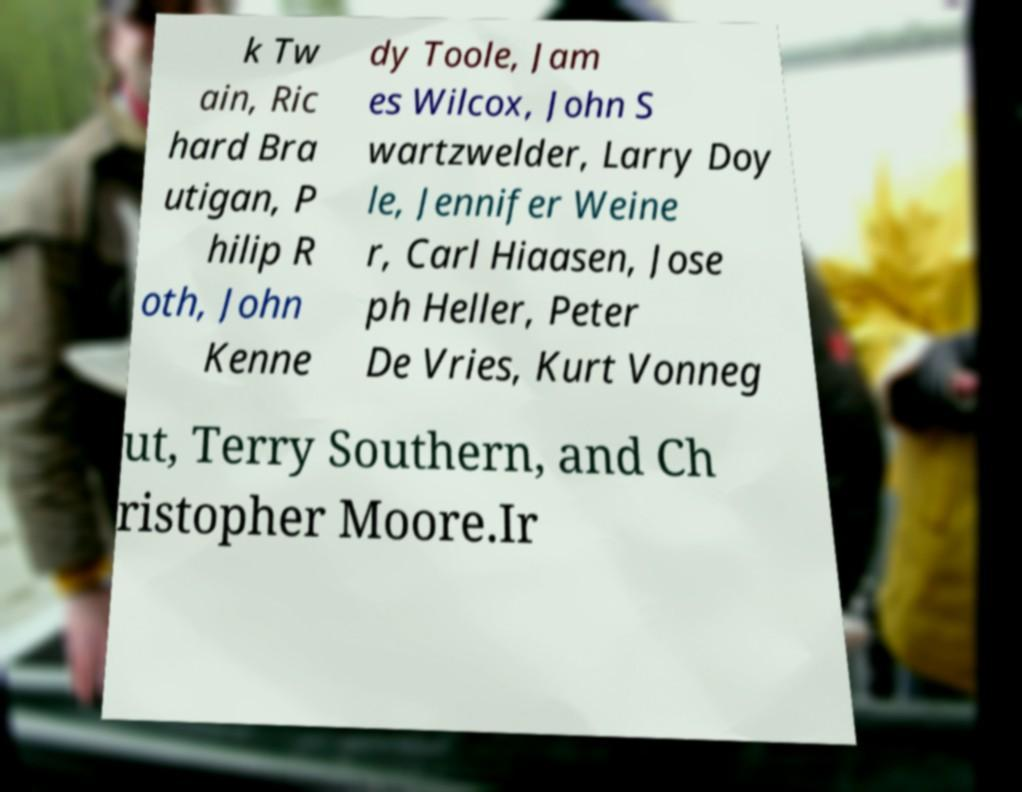I need the written content from this picture converted into text. Can you do that? k Tw ain, Ric hard Bra utigan, P hilip R oth, John Kenne dy Toole, Jam es Wilcox, John S wartzwelder, Larry Doy le, Jennifer Weine r, Carl Hiaasen, Jose ph Heller, Peter De Vries, Kurt Vonneg ut, Terry Southern, and Ch ristopher Moore.Ir 